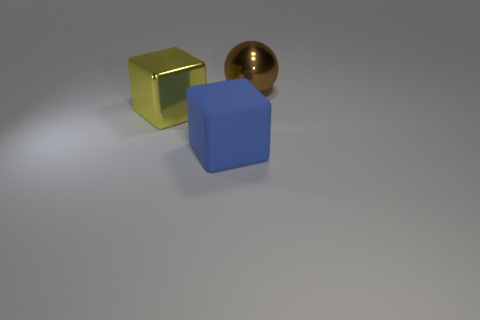What size is the object that is both to the right of the yellow cube and in front of the big brown metallic object?
Provide a succinct answer. Large. There is a large blue object; is its shape the same as the metal object that is to the left of the blue cube?
Ensure brevity in your answer.  Yes. Are there any other things that have the same material as the large blue object?
Your answer should be compact. No. There is a large yellow thing that is the same shape as the large blue object; what material is it?
Offer a terse response. Metal. What number of large objects are either cyan cubes or yellow blocks?
Provide a short and direct response. 1. Are there fewer big metal objects on the left side of the rubber thing than big objects on the left side of the brown shiny object?
Ensure brevity in your answer.  Yes. What number of things are either blue matte objects or yellow metal things?
Your response must be concise. 2. There is a brown shiny ball; what number of large yellow things are in front of it?
Keep it short and to the point. 1. Do the big matte object and the sphere have the same color?
Your answer should be very brief. No. What is the shape of the brown object that is made of the same material as the yellow object?
Ensure brevity in your answer.  Sphere. 